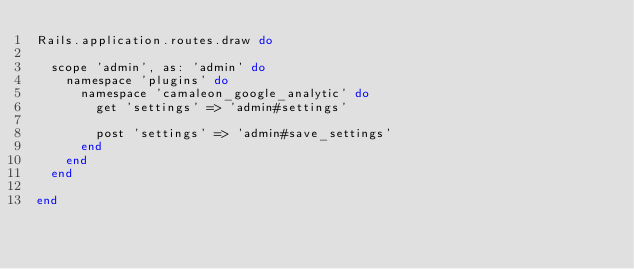Convert code to text. <code><loc_0><loc_0><loc_500><loc_500><_Ruby_>Rails.application.routes.draw do

  scope 'admin', as: 'admin' do
    namespace 'plugins' do
      namespace 'camaleon_google_analytic' do
        get 'settings' => 'admin#settings'

        post 'settings' => 'admin#save_settings'
      end
    end
  end

end

</code> 